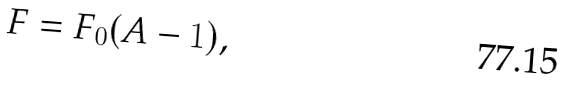Convert formula to latex. <formula><loc_0><loc_0><loc_500><loc_500>F = F _ { 0 } ( A - 1 ) ,</formula> 